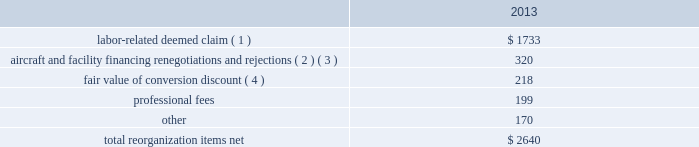Table of contents the following discussion of nonoperating income and expense excludes the results of us airways in order to provide a more meaningful year-over-year comparison .
Interest expense , net of capitalized interest decreased $ 129 million in 2014 from 2013 primarily due to a $ 63 million decrease in special charges recognized year-over-year as further described below , as well as refinancing activities that resulted in $ 65 million less interest expense recognized in 2014 .
( 1 ) in 2014 , american recognized $ 29 million of special charges relating to non-cash interest accretion on bankruptcy settlement obligations .
In 2013 , american recognized $ 48 million of special charges relating to post-petition interest expense on unsecured obligations pursuant to the plan and penalty interest related to american 2019s 10.5% ( 10.5 % ) secured notes and 7.50% ( 7.50 % ) senior secured notes .
In addition , in 2013 american recorded special charges of $ 44 million for debt extinguishment costs incurred as a result of the repayment of certain aircraft secured indebtedness , including cash interest charges and non-cash write offs of unamortized debt issuance costs .
( 2 ) as a result of the 2013 refinancing activities and the early extinguishment of american 2019s 7.50% ( 7.50 % ) senior secured notes in 2014 , american incurred $ 65 million less interest expense in 2014 as compared to 2013 .
Other nonoperating expense , net in 2014 consisted of $ 92 million of net foreign currency losses , including a $ 43 million special charge for venezuelan foreign currency losses , and $ 48 million of early debt extinguishment costs related to the prepayment of american 2019s 7.50% ( 7.50 % ) senior secured notes and other indebtedness .
The foreign currency losses were driven primarily by the strengthening of the u.s .
Dollar relative to other currencies during 2014 , principally in the latin american market , including a 48% ( 48 % ) decrease in the value of the venezuelan bolivar and a 14% ( 14 % ) decrease in the value of the brazilian real .
Other nonoperating expense , net in 2013 consisted principally of net foreign currency losses of $ 55 million and early debt extinguishment charges of $ 29 million .
Reorganization items , net reorganization items refer to revenues , expenses ( including professional fees ) , realized gains and losses and provisions for losses that are realized or incurred as a direct result of the chapter 11 cases .
The table summarizes the components included in reorganization items , net on american 2019s consolidated statement of operations for the year ended december 31 , 2013 ( in millions ) : .
( 1 ) in exchange for employees 2019 contributions to the successful reorganization , including agreeing to reductions in pay and benefits , american agreed in the plan to provide each employee group a deemed claim , which was used to provide a distribution of a portion of the equity of the reorganized entity to those employees .
Each employee group received a deemed claim amount based upon a portion of the value of cost savings provided by that group through reductions to pay and benefits as well as through certain work rule changes .
The total value of this deemed claim was approximately $ 1.7 billion .
( 2 ) amounts include allowed claims ( claims approved by the bankruptcy court ) and estimated allowed claims relating to ( i ) the rejection or modification of financings related to aircraft and ( ii ) entry of orders treated as unsecured claims with respect to facility agreements supporting certain issuances of special facility revenue .
What percentage of total 2013 reorganization items consisted of fair value of conversion discount? 
Computations: (218 / 2640)
Answer: 0.08258. 